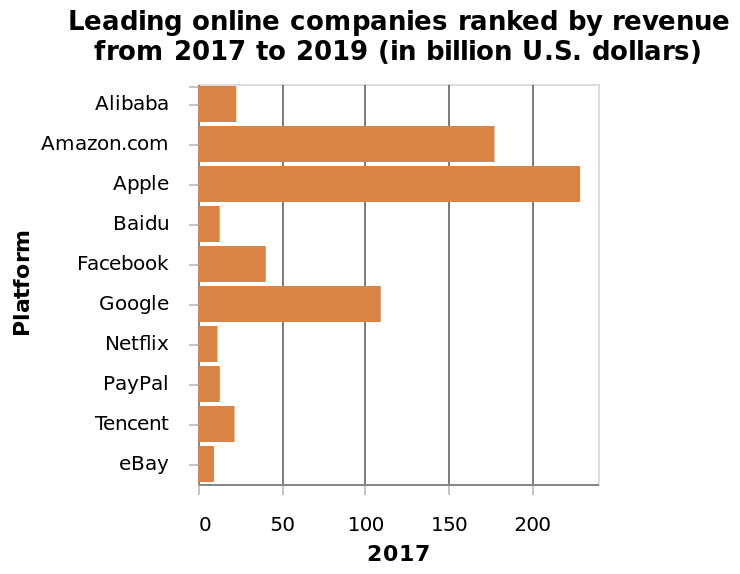<image>
please enumerates aspects of the construction of the chart Here a is a bar chart called Leading online companies ranked by revenue from 2017 to 2019 (in billion U.S. dollars). There is a categorical scale from Alibaba to  along the y-axis, labeled Platform. The x-axis shows 2017 on a linear scale from 0 to 200. What is the title of the bar chart?  The title of the bar chart is "Leading online companies ranked by revenue from 2017 to 2019 (in billion U.S. dollars)". How many online companies had revenues between $10 to $40 billion? There are 7 online companies whose revenues were between $10 to $40 billion. 